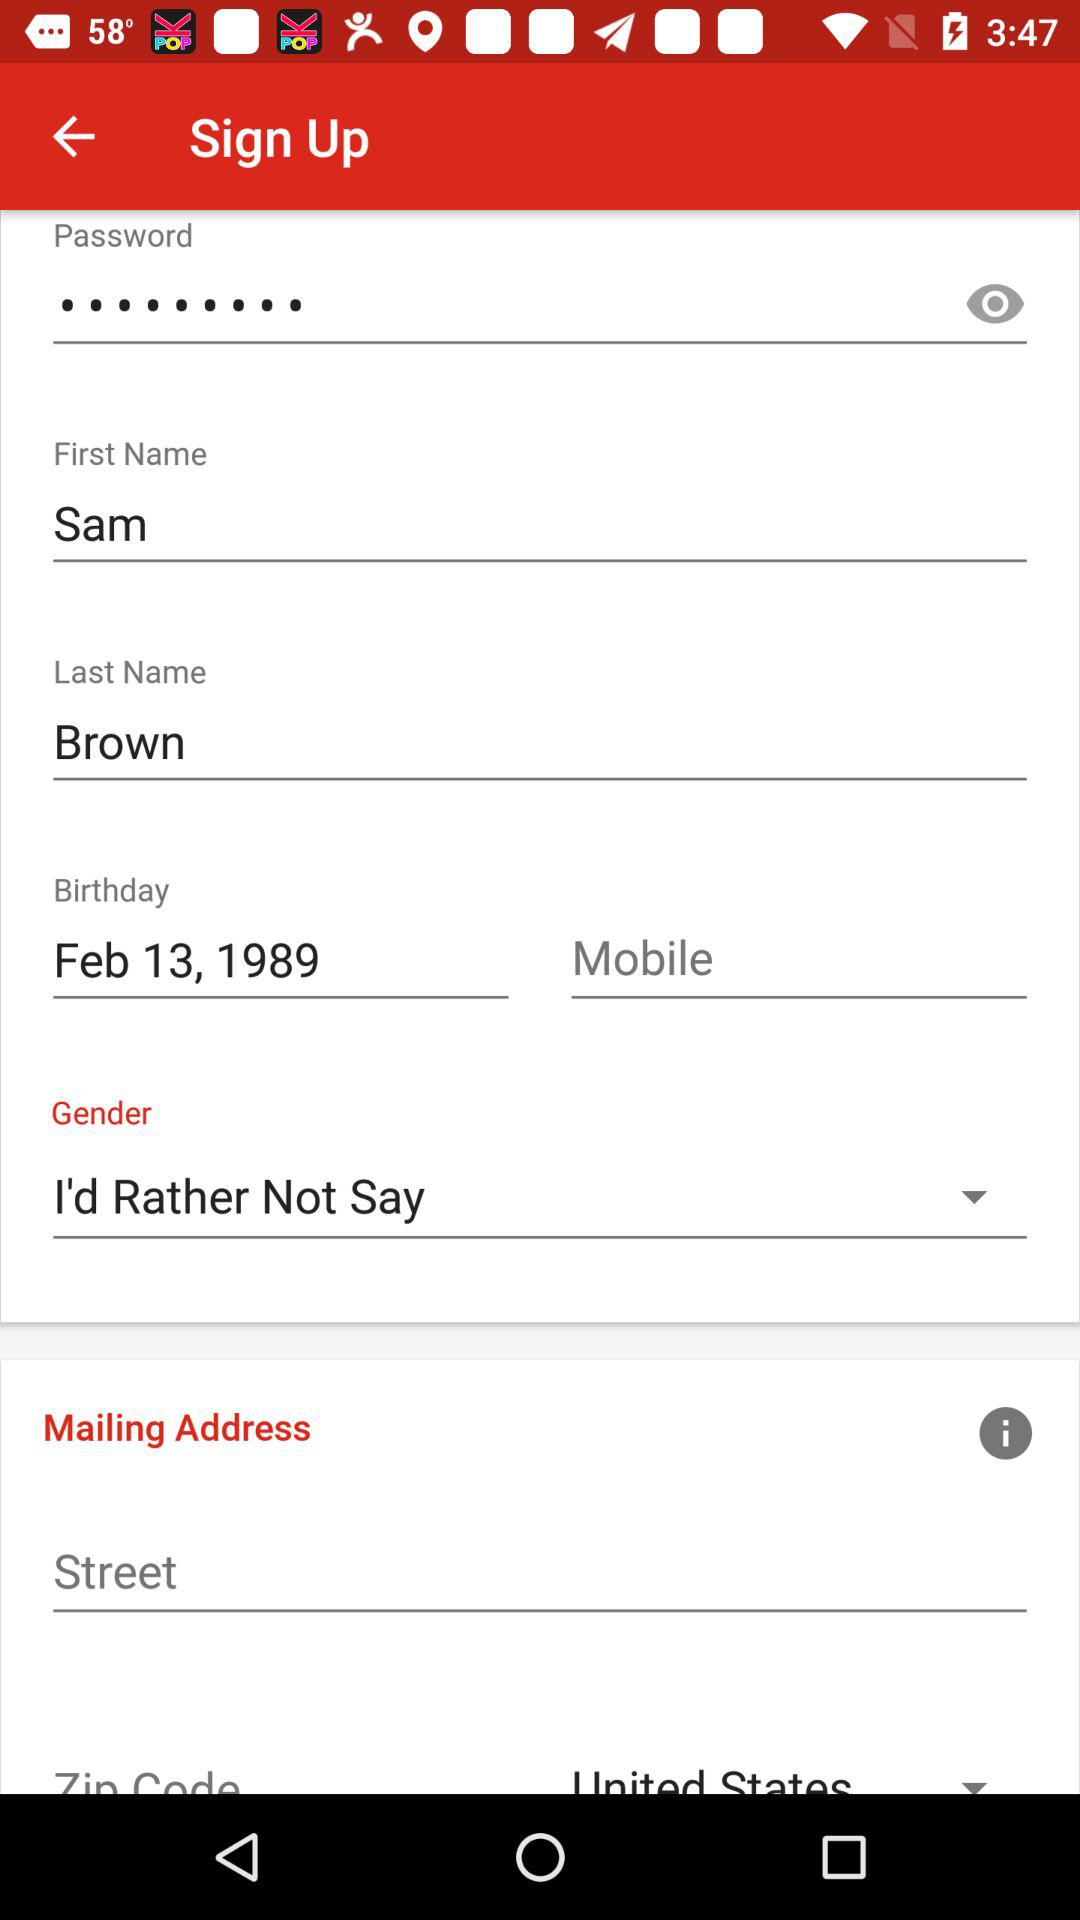What is the given date of birth? The given date of birth is February 13, 1989. 